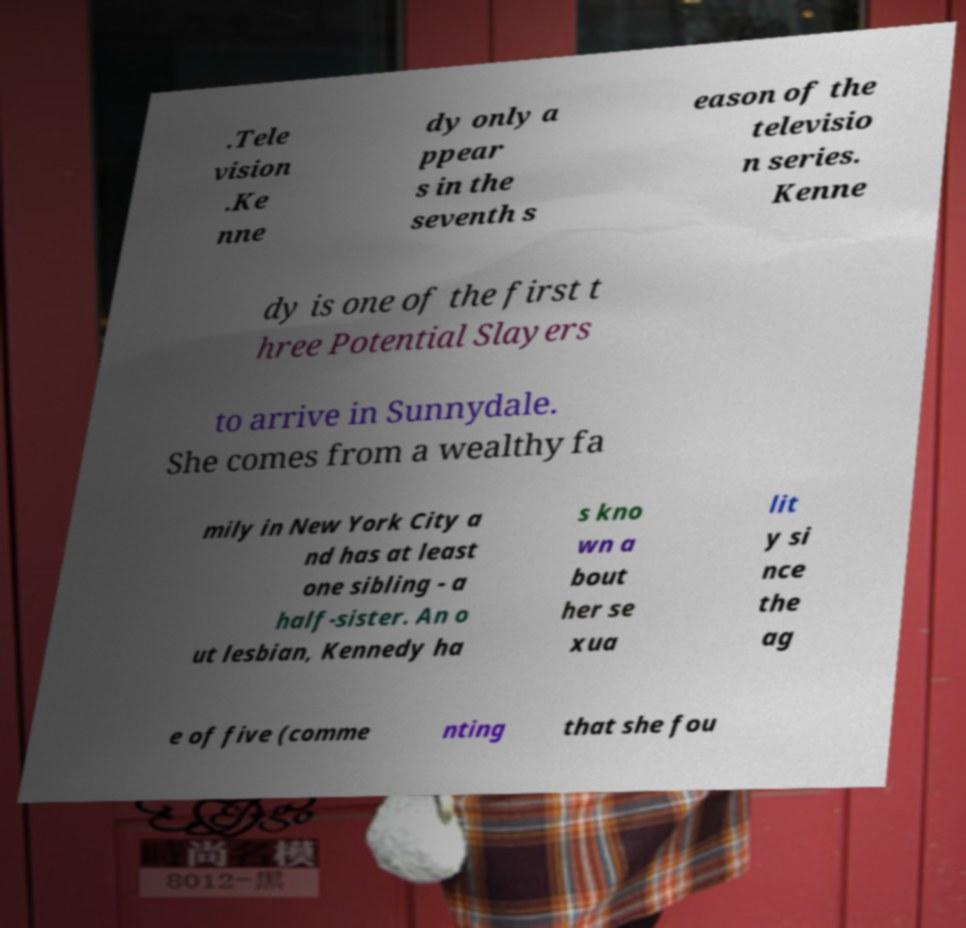Can you accurately transcribe the text from the provided image for me? .Tele vision .Ke nne dy only a ppear s in the seventh s eason of the televisio n series. Kenne dy is one of the first t hree Potential Slayers to arrive in Sunnydale. She comes from a wealthy fa mily in New York City a nd has at least one sibling - a half-sister. An o ut lesbian, Kennedy ha s kno wn a bout her se xua lit y si nce the ag e of five (comme nting that she fou 